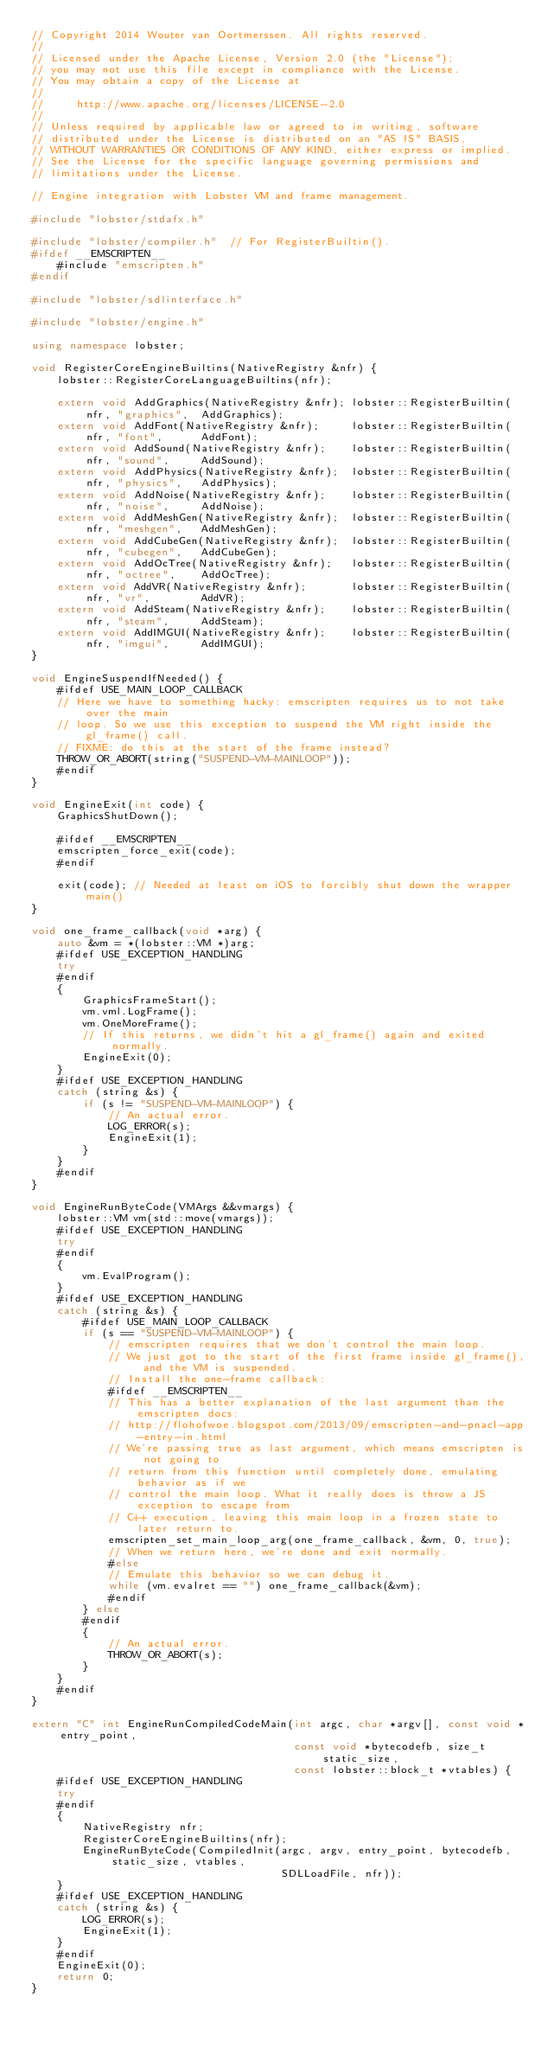Convert code to text. <code><loc_0><loc_0><loc_500><loc_500><_C++_>// Copyright 2014 Wouter van Oortmerssen. All rights reserved.
//
// Licensed under the Apache License, Version 2.0 (the "License");
// you may not use this file except in compliance with the License.
// You may obtain a copy of the License at
//
//     http://www.apache.org/licenses/LICENSE-2.0
//
// Unless required by applicable law or agreed to in writing, software
// distributed under the License is distributed on an "AS IS" BASIS,
// WITHOUT WARRANTIES OR CONDITIONS OF ANY KIND, either express or implied.
// See the License for the specific language governing permissions and
// limitations under the License.

// Engine integration with Lobster VM and frame management.

#include "lobster/stdafx.h"

#include "lobster/compiler.h"  // For RegisterBuiltin().
#ifdef __EMSCRIPTEN__
    #include "emscripten.h"
#endif

#include "lobster/sdlinterface.h"

#include "lobster/engine.h"

using namespace lobster;

void RegisterCoreEngineBuiltins(NativeRegistry &nfr) {
    lobster::RegisterCoreLanguageBuiltins(nfr);

    extern void AddGraphics(NativeRegistry &nfr); lobster::RegisterBuiltin(nfr, "graphics",  AddGraphics);
    extern void AddFont(NativeRegistry &nfr);     lobster::RegisterBuiltin(nfr, "font",      AddFont);
    extern void AddSound(NativeRegistry &nfr);    lobster::RegisterBuiltin(nfr, "sound",     AddSound);
    extern void AddPhysics(NativeRegistry &nfr);  lobster::RegisterBuiltin(nfr, "physics",   AddPhysics);
    extern void AddNoise(NativeRegistry &nfr);    lobster::RegisterBuiltin(nfr, "noise",     AddNoise);
    extern void AddMeshGen(NativeRegistry &nfr);  lobster::RegisterBuiltin(nfr, "meshgen",   AddMeshGen);
    extern void AddCubeGen(NativeRegistry &nfr);  lobster::RegisterBuiltin(nfr, "cubegen",   AddCubeGen);
    extern void AddOcTree(NativeRegistry &nfr);   lobster::RegisterBuiltin(nfr, "octree",    AddOcTree);
    extern void AddVR(NativeRegistry &nfr);       lobster::RegisterBuiltin(nfr, "vr",        AddVR);
    extern void AddSteam(NativeRegistry &nfr);    lobster::RegisterBuiltin(nfr, "steam",     AddSteam);
    extern void AddIMGUI(NativeRegistry &nfr);    lobster::RegisterBuiltin(nfr, "imgui",     AddIMGUI);
}

void EngineSuspendIfNeeded() {
    #ifdef USE_MAIN_LOOP_CALLBACK
    // Here we have to something hacky: emscripten requires us to not take over the main
    // loop. So we use this exception to suspend the VM right inside the gl_frame() call.
    // FIXME: do this at the start of the frame instead?
    THROW_OR_ABORT(string("SUSPEND-VM-MAINLOOP"));
    #endif
}

void EngineExit(int code) {
    GraphicsShutDown();

    #ifdef __EMSCRIPTEN__
    emscripten_force_exit(code);
    #endif

    exit(code); // Needed at least on iOS to forcibly shut down the wrapper main()
}

void one_frame_callback(void *arg) {
    auto &vm = *(lobster::VM *)arg;
    #ifdef USE_EXCEPTION_HANDLING
    try
    #endif
    {
        GraphicsFrameStart();
        vm.vml.LogFrame();
        vm.OneMoreFrame();
        // If this returns, we didn't hit a gl_frame() again and exited normally.
        EngineExit(0);
    }
    #ifdef USE_EXCEPTION_HANDLING
    catch (string &s) {
        if (s != "SUSPEND-VM-MAINLOOP") {
            // An actual error.
            LOG_ERROR(s);
            EngineExit(1);
        }
    }
    #endif
}

void EngineRunByteCode(VMArgs &&vmargs) {
    lobster::VM vm(std::move(vmargs));
    #ifdef USE_EXCEPTION_HANDLING
    try
    #endif
    {
        vm.EvalProgram();
    }
    #ifdef USE_EXCEPTION_HANDLING
    catch (string &s) {
        #ifdef USE_MAIN_LOOP_CALLBACK
        if (s == "SUSPEND-VM-MAINLOOP") {
            // emscripten requires that we don't control the main loop.
            // We just got to the start of the first frame inside gl_frame(), and the VM is suspended.
            // Install the one-frame callback:
            #ifdef __EMSCRIPTEN__
            // This has a better explanation of the last argument than the emscripten docs:
            // http://flohofwoe.blogspot.com/2013/09/emscripten-and-pnacl-app-entry-in.html
            // We're passing true as last argument, which means emscripten is not going to
            // return from this function until completely done, emulating behavior as if we
            // control the main loop. What it really does is throw a JS exception to escape from
            // C++ execution, leaving this main loop in a frozen state to later return to.
            emscripten_set_main_loop_arg(one_frame_callback, &vm, 0, true);
            // When we return here, we're done and exit normally.
            #else
            // Emulate this behavior so we can debug it.
            while (vm.evalret == "") one_frame_callback(&vm);
            #endif
        } else
        #endif
        {
            // An actual error.
            THROW_OR_ABORT(s);
        }
    }
    #endif
}

extern "C" int EngineRunCompiledCodeMain(int argc, char *argv[], const void *entry_point,
                                         const void *bytecodefb, size_t static_size,
                                         const lobster::block_t *vtables) {
    #ifdef USE_EXCEPTION_HANDLING
    try
    #endif
    {
        NativeRegistry nfr;
        RegisterCoreEngineBuiltins(nfr);
        EngineRunByteCode(CompiledInit(argc, argv, entry_point, bytecodefb, static_size, vtables,
                                       SDLLoadFile, nfr));
    }
    #ifdef USE_EXCEPTION_HANDLING
    catch (string &s) {
        LOG_ERROR(s);
        EngineExit(1);
    }
    #endif
    EngineExit(0);
    return 0;
}
</code> 